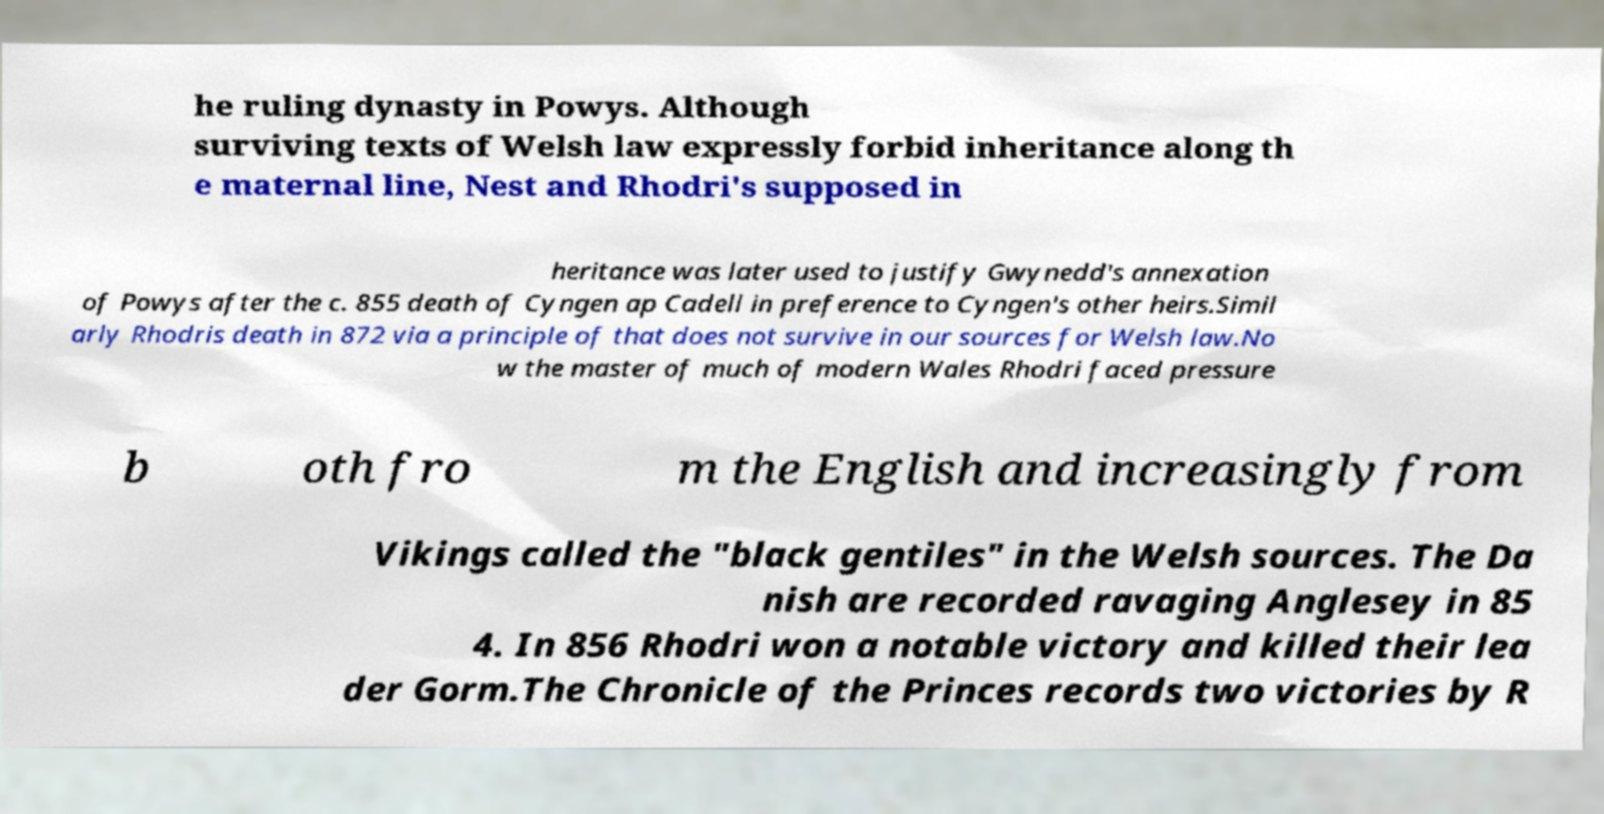What messages or text are displayed in this image? I need them in a readable, typed format. he ruling dynasty in Powys. Although surviving texts of Welsh law expressly forbid inheritance along th e maternal line, Nest and Rhodri's supposed in heritance was later used to justify Gwynedd's annexation of Powys after the c. 855 death of Cyngen ap Cadell in preference to Cyngen's other heirs.Simil arly Rhodris death in 872 via a principle of that does not survive in our sources for Welsh law.No w the master of much of modern Wales Rhodri faced pressure b oth fro m the English and increasingly from Vikings called the "black gentiles" in the Welsh sources. The Da nish are recorded ravaging Anglesey in 85 4. In 856 Rhodri won a notable victory and killed their lea der Gorm.The Chronicle of the Princes records two victories by R 